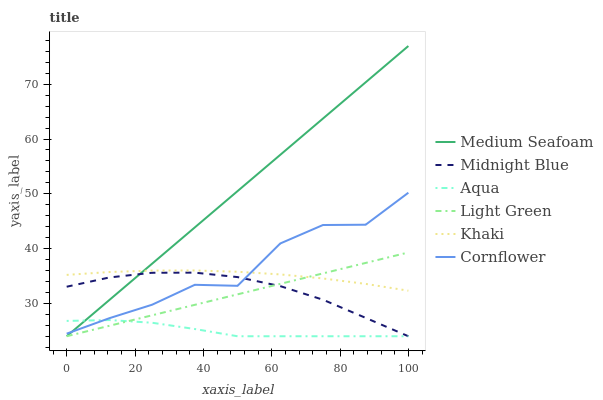Does Aqua have the minimum area under the curve?
Answer yes or no. Yes. Does Medium Seafoam have the maximum area under the curve?
Answer yes or no. Yes. Does Khaki have the minimum area under the curve?
Answer yes or no. No. Does Khaki have the maximum area under the curve?
Answer yes or no. No. Is Light Green the smoothest?
Answer yes or no. Yes. Is Cornflower the roughest?
Answer yes or no. Yes. Is Khaki the smoothest?
Answer yes or no. No. Is Khaki the roughest?
Answer yes or no. No. Does Midnight Blue have the lowest value?
Answer yes or no. Yes. Does Khaki have the lowest value?
Answer yes or no. No. Does Medium Seafoam have the highest value?
Answer yes or no. Yes. Does Khaki have the highest value?
Answer yes or no. No. Is Midnight Blue less than Khaki?
Answer yes or no. Yes. Is Khaki greater than Aqua?
Answer yes or no. Yes. Does Aqua intersect Medium Seafoam?
Answer yes or no. Yes. Is Aqua less than Medium Seafoam?
Answer yes or no. No. Is Aqua greater than Medium Seafoam?
Answer yes or no. No. Does Midnight Blue intersect Khaki?
Answer yes or no. No. 